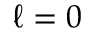<formula> <loc_0><loc_0><loc_500><loc_500>\ell = 0</formula> 